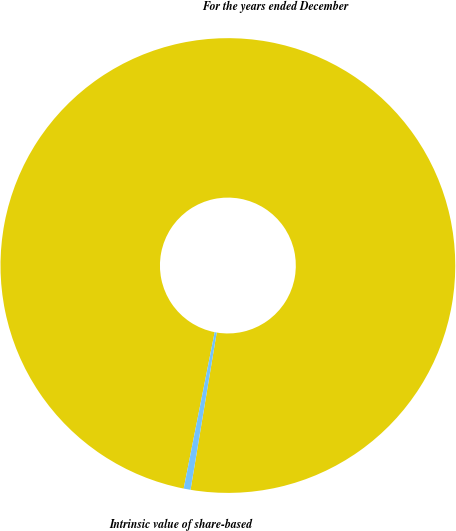<chart> <loc_0><loc_0><loc_500><loc_500><pie_chart><fcel>For the years ended December<fcel>Intrinsic value of share-based<nl><fcel>99.51%<fcel>0.49%<nl></chart> 